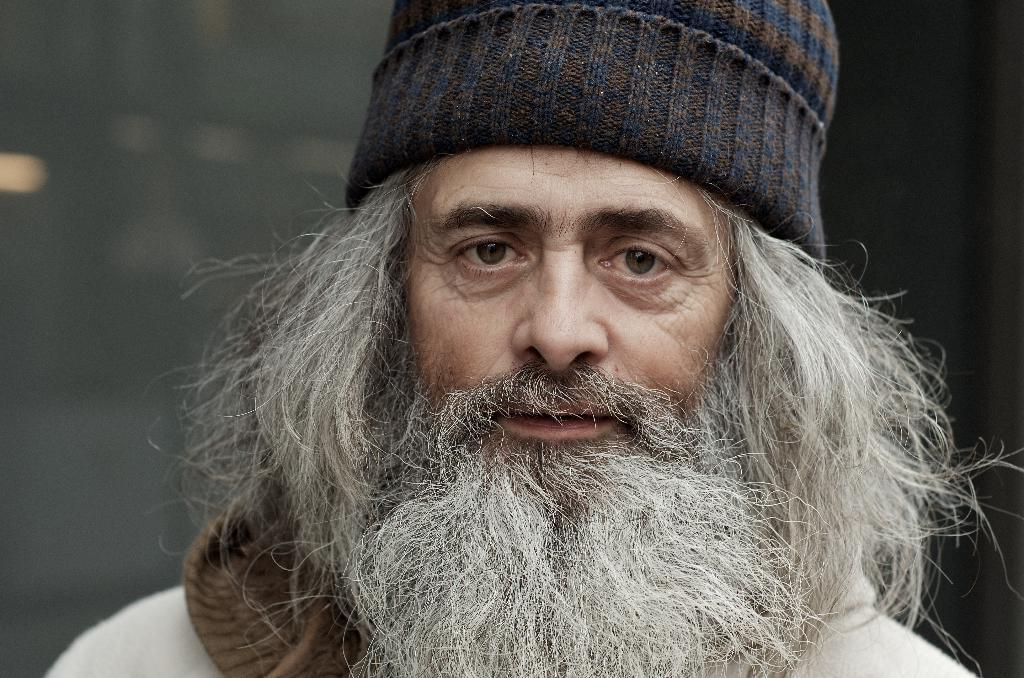Who is present in the image? There is a man in the picture. What is the man wearing on his head? The man is wearing a cap. Can you describe the background of the image? The background of the image is blurry. How many legs can be seen on the cap in the image? There are no legs visible on the cap in the image, as caps do not have legs. 